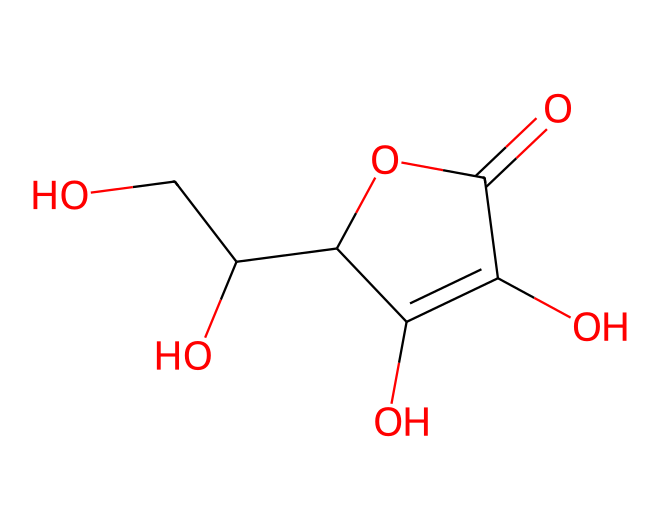What is the name of this vitamin? The SMILES representation indicates this structure corresponds to ascorbic acid, commonly known as vitamin C.
Answer: vitamin C How many hydroxyl groups are present in this structure? Examining the structure, there are four -OH groups, which are characterized by the presence of oxygen bonded to hydrogen.
Answer: four What type of functional group does this vitamin contain? The presence of the carboxylic acid moiety (-COOH) in the structure indicates it contains a carboxylic acid functional group.
Answer: carboxylic acid What is the total number of carbon atoms in this vitamin? Counting the carbon atoms in the SMILES representation, there are six carbon atoms present in the structure.
Answer: six How many double bonds are present in this chemical structure? Observing the structural representation, there is one double bond between carbon and oxygen in the carboxylic acid group as well as one double bond between the two carbons in the ring structure. Therefore, there are two double bonds.
Answer: two What role does the oxygen atom play in the structure of this vitamin? The oxygen atoms are involved in the formation of hydroxyl (-OH) groups and the carboxylic acid functional group, which are crucial for the vitamin’s reactivity and solubility in water.
Answer: hydroxyl groups and carboxylic acid In what way can the structure of this vitamin be analogous to a distributed storage system? Both vitamin C's structure, with its multiple interconnected bonds, and a distributed storage system, with its interconnected nodes, showcase how individual components (bonds/nodes) contribute to the overall stability and functionality of a complex system.
Answer: interconnected components 